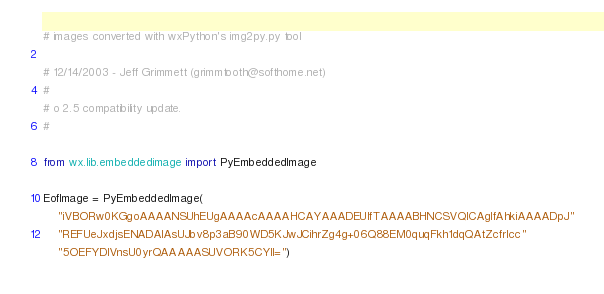<code> <loc_0><loc_0><loc_500><loc_500><_Python_>
# images converted with wxPython's img2py.py tool

# 12/14/2003 - Jeff Grimmett (grimmtooth@softhome.net)
#
# o 2.5 compatibility update.
#

from wx.lib.embeddedimage import PyEmbeddedImage

EofImage = PyEmbeddedImage(
    "iVBORw0KGgoAAAANSUhEUgAAAAcAAAAHCAYAAADEUlfTAAAABHNCSVQICAgIfAhkiAAAADpJ"
    "REFUeJxdjsENADAIAsUJbv8p3aB90WD5KJwJCihrZg4g+06Q88EM0quqFkh1dqQAtZcfrIcc"
    "5OEFYDIVnsU0yrQAAAAASUVORK5CYII=")

</code> 